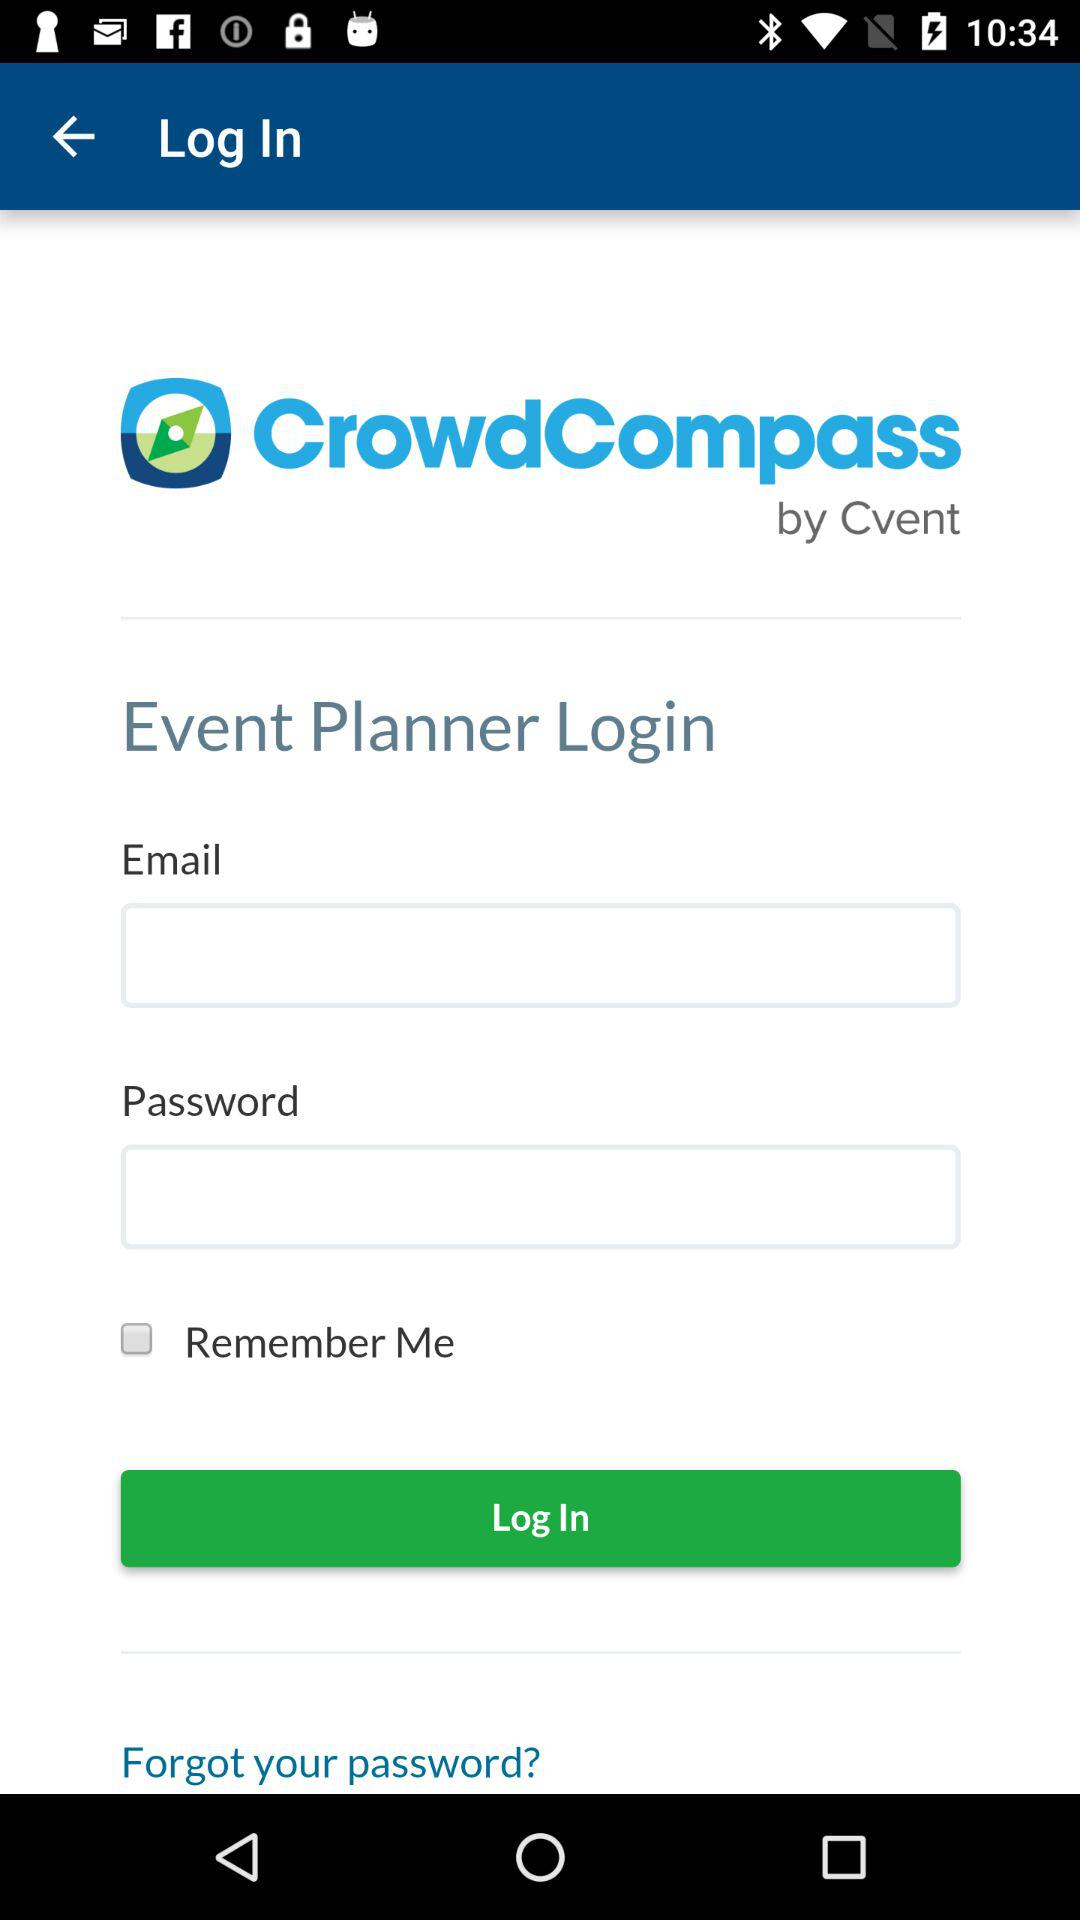How many more text inputs are there than checkboxes?
Answer the question using a single word or phrase. 1 